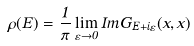<formula> <loc_0><loc_0><loc_500><loc_500>\rho ( E ) = \frac { 1 } { \pi } \lim _ { \varepsilon \rightarrow 0 } I m G _ { E + i \varepsilon } ( x , x )</formula> 